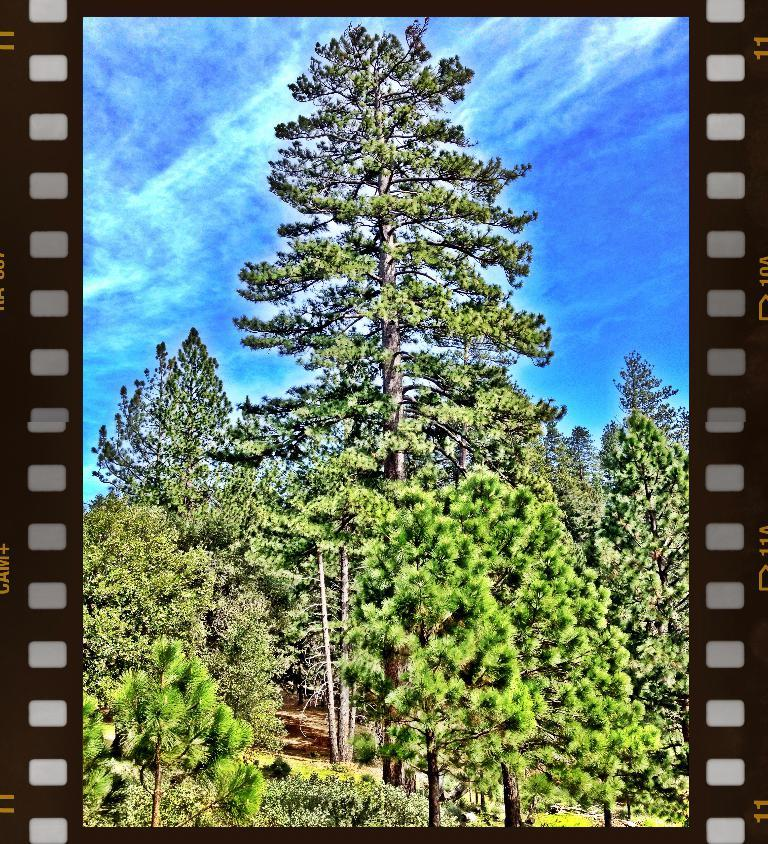What type of vegetation is present in the image? There are many trees in the image. What color is the sky in the background of the image? The blue sky is visible in the background of the image. What type of polish is being applied to the trees in the image? There is no polish being applied to the trees in the image; they are simply standing in their natural state. 